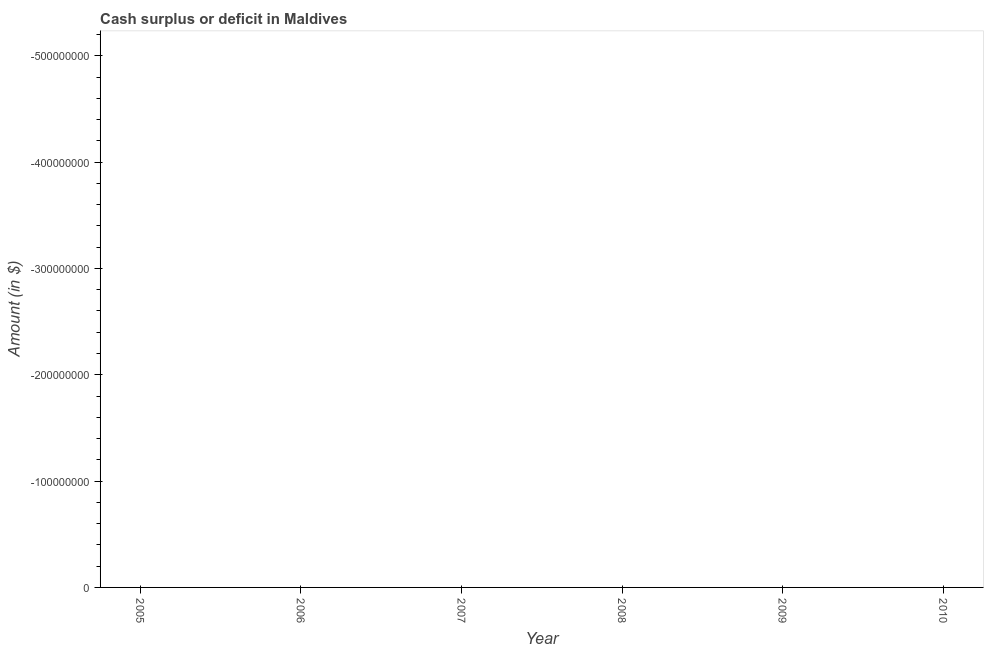What is the sum of the cash surplus or deficit?
Your answer should be very brief. 0. What is the median cash surplus or deficit?
Offer a terse response. 0. In how many years, is the cash surplus or deficit greater than -240000000 $?
Offer a very short reply. 0. In how many years, is the cash surplus or deficit greater than the average cash surplus or deficit taken over all years?
Offer a terse response. 0. Does the cash surplus or deficit monotonically increase over the years?
Ensure brevity in your answer.  No. What is the difference between two consecutive major ticks on the Y-axis?
Your answer should be very brief. 1.00e+08. Are the values on the major ticks of Y-axis written in scientific E-notation?
Offer a very short reply. No. Does the graph contain any zero values?
Give a very brief answer. Yes. Does the graph contain grids?
Keep it short and to the point. No. What is the title of the graph?
Ensure brevity in your answer.  Cash surplus or deficit in Maldives. What is the label or title of the X-axis?
Your answer should be very brief. Year. What is the label or title of the Y-axis?
Your response must be concise. Amount (in $). What is the Amount (in $) of 2006?
Give a very brief answer. 0. What is the Amount (in $) in 2007?
Ensure brevity in your answer.  0. What is the Amount (in $) in 2008?
Offer a very short reply. 0. What is the Amount (in $) of 2010?
Your response must be concise. 0. 